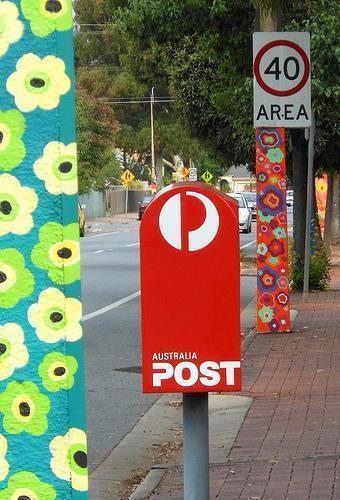How many streets are there?
Give a very brief answer. 1. 